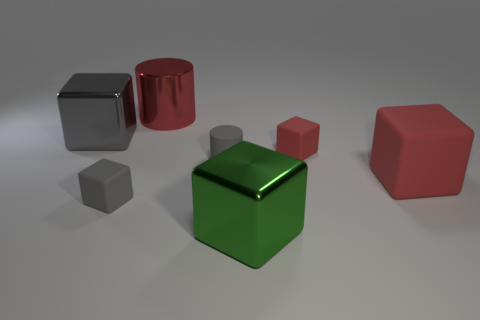Subtract all big matte cubes. How many cubes are left? 4 Subtract all green spheres. How many gray cubes are left? 2 Add 2 small matte objects. How many objects exist? 9 Subtract all red cubes. How many cubes are left? 3 Subtract all cubes. How many objects are left? 2 Subtract 3 blocks. How many blocks are left? 2 Subtract all green cylinders. Subtract all brown balls. How many cylinders are left? 2 Subtract all big shiny cubes. Subtract all small red rubber things. How many objects are left? 4 Add 2 small matte cylinders. How many small matte cylinders are left? 3 Add 1 large green metallic cubes. How many large green metallic cubes exist? 2 